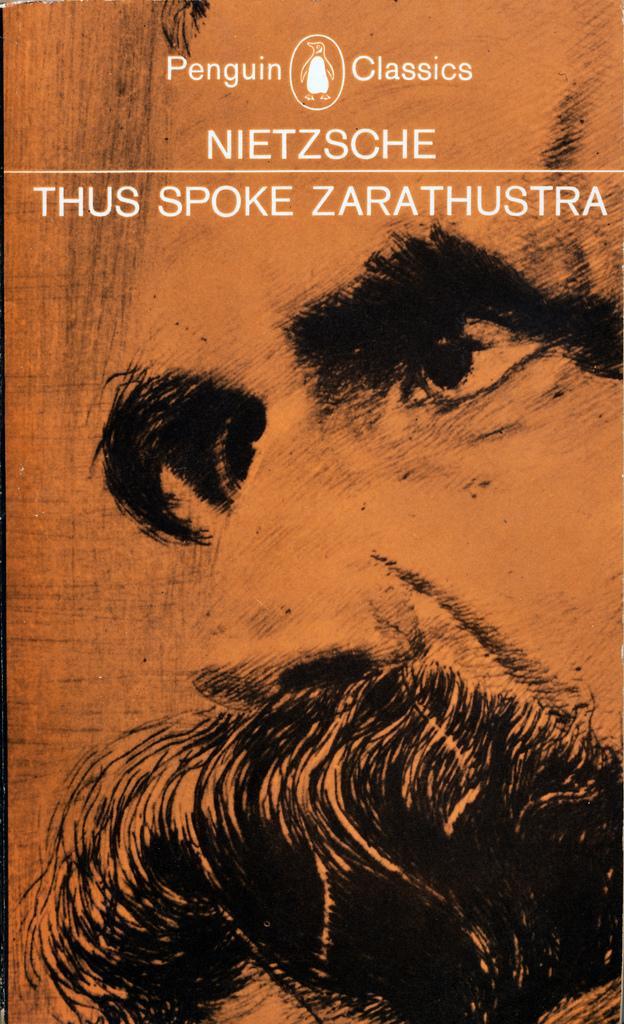Describe this image in one or two sentences. In this image, we can see a poster with some image and text. 